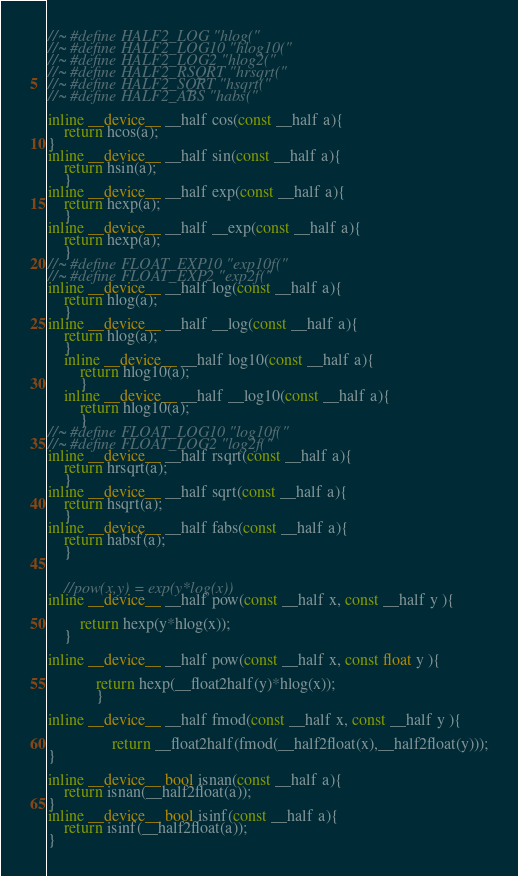Convert code to text. <code><loc_0><loc_0><loc_500><loc_500><_Cuda_>//~ #define HALF2_LOG "hlog("
//~ #define HALF2_LOG10 "hlog10("
//~ #define HALF2_LOG2 "hlog2("
//~ #define HALF2_RSQRT "hrsqrt("
//~ #define HALF2_SQRT "hsqrt("
//~ #define HALF2_ABS "habs("

inline __device__ __half cos(const __half a){
	return hcos(a);
}
inline __device__ __half sin(const __half a){
	return hsin(a);
	}
inline __device__ __half exp(const __half a){
	return hexp(a);
	}
inline __device__ __half __exp(const __half a){
	return hexp(a);
	}
//~ #define FLOAT_EXP10 "exp10f("
//~ #define FLOAT_EXP2 "exp2f("
inline __device__ __half log(const __half a){
	return hlog(a);
	}
inline __device__ __half __log(const __half a){
	return hlog(a);
	}
	inline __device__ __half log10(const __half a){
		return hlog10(a);
		}
	inline __device__ __half __log10(const __half a){
		return hlog10(a);
		}
//~ #define FLOAT_LOG10 "log10f("
//~ #define FLOAT_LOG2 "log2f("
inline __device__ __half rsqrt(const __half a){
	return hrsqrt(a);
	}
inline __device__ __half sqrt(const __half a){
	return hsqrt(a);
	}
inline __device__ __half fabs(const __half a){
	return habsf(a);
	}


	//pow(x,y) = exp(y*log(x))
inline __device__ __half pow(const __half x, const __half y ){

		return hexp(y*hlog(x));
	}

inline __device__ __half pow(const __half x, const float y ){

			return hexp(__float2half(y)*hlog(x));
			}

inline __device__ __half fmod(const __half x, const __half y ){

				return __float2half(fmod(__half2float(x),__half2float(y)));
}

inline __device__ bool isnan(const __half a){
	return isnan(__half2float(a));
}
inline __device__ bool isinf(const __half a){
	return isinf(__half2float(a));
}
</code> 